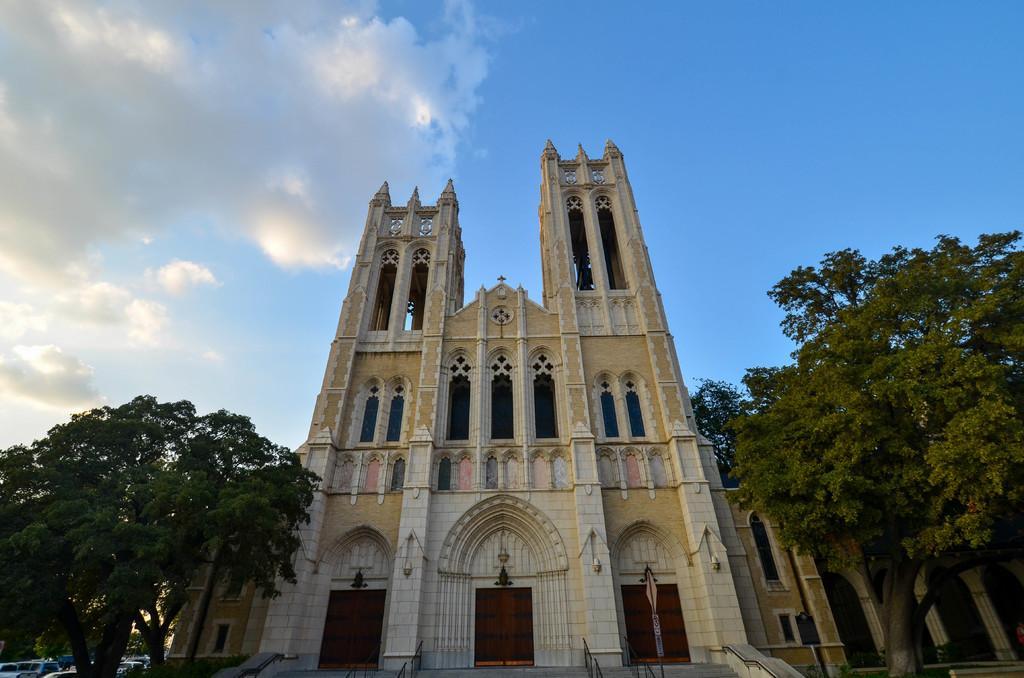Describe this image in one or two sentences. At the bottom of the image there are some trees and buildings and vehicles and poles. At the top of the image there are some clouds and sky. 